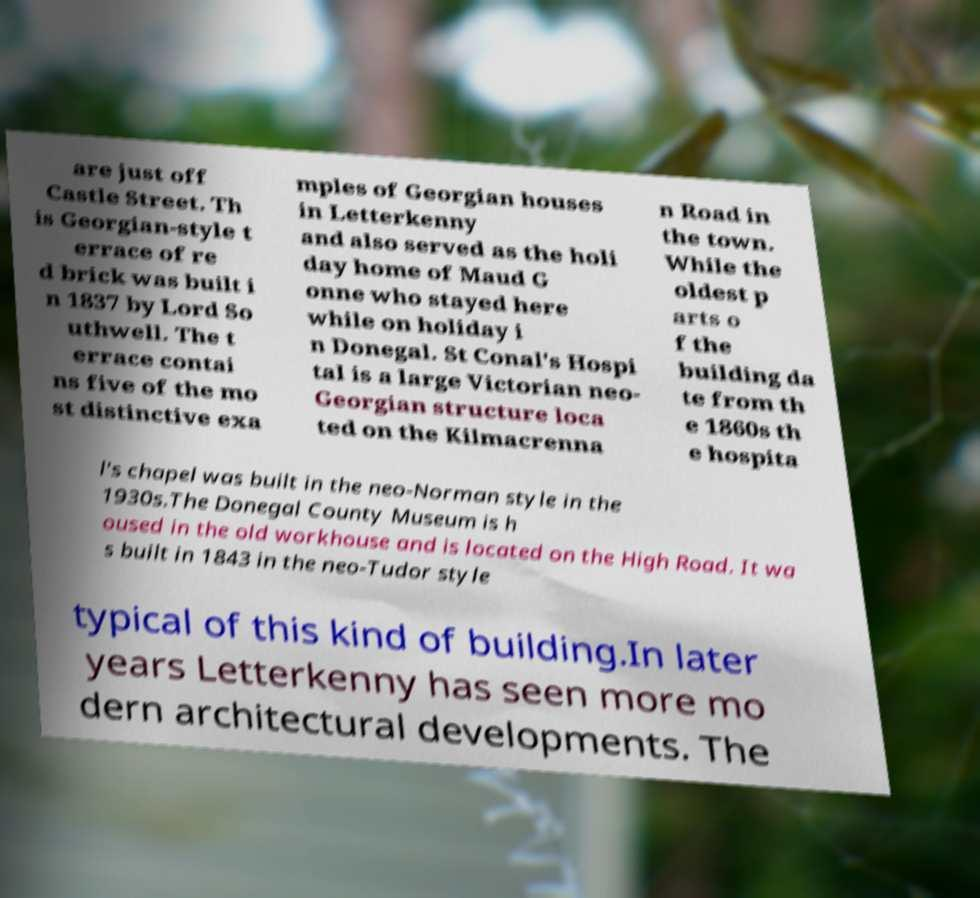For documentation purposes, I need the text within this image transcribed. Could you provide that? are just off Castle Street. Th is Georgian-style t errace of re d brick was built i n 1837 by Lord So uthwell. The t errace contai ns five of the mo st distinctive exa mples of Georgian houses in Letterkenny and also served as the holi day home of Maud G onne who stayed here while on holiday i n Donegal. St Conal's Hospi tal is a large Victorian neo- Georgian structure loca ted on the Kilmacrenna n Road in the town. While the oldest p arts o f the building da te from th e 1860s th e hospita l's chapel was built in the neo-Norman style in the 1930s.The Donegal County Museum is h oused in the old workhouse and is located on the High Road. It wa s built in 1843 in the neo-Tudor style typical of this kind of building.In later years Letterkenny has seen more mo dern architectural developments. The 